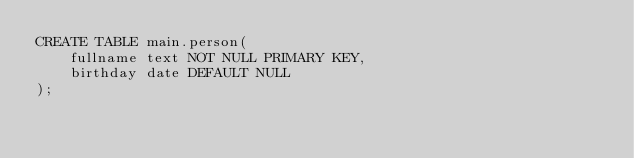Convert code to text. <code><loc_0><loc_0><loc_500><loc_500><_SQL_>CREATE TABLE main.person(
    fullname text NOT NULL PRIMARY KEY,
    birthday date DEFAULT NULL
);</code> 